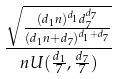<formula> <loc_0><loc_0><loc_500><loc_500>\frac { \sqrt { \frac { ( d _ { 1 } n ) ^ { d _ { 1 } } d _ { 7 } ^ { d _ { 7 } } } { ( d _ { 1 } n + d _ { 7 } ) ^ { d _ { 1 } + d _ { 7 } } } } } { n U ( \frac { d _ { 1 } } { 7 } , \frac { d _ { 7 } } { 7 } ) }</formula> 